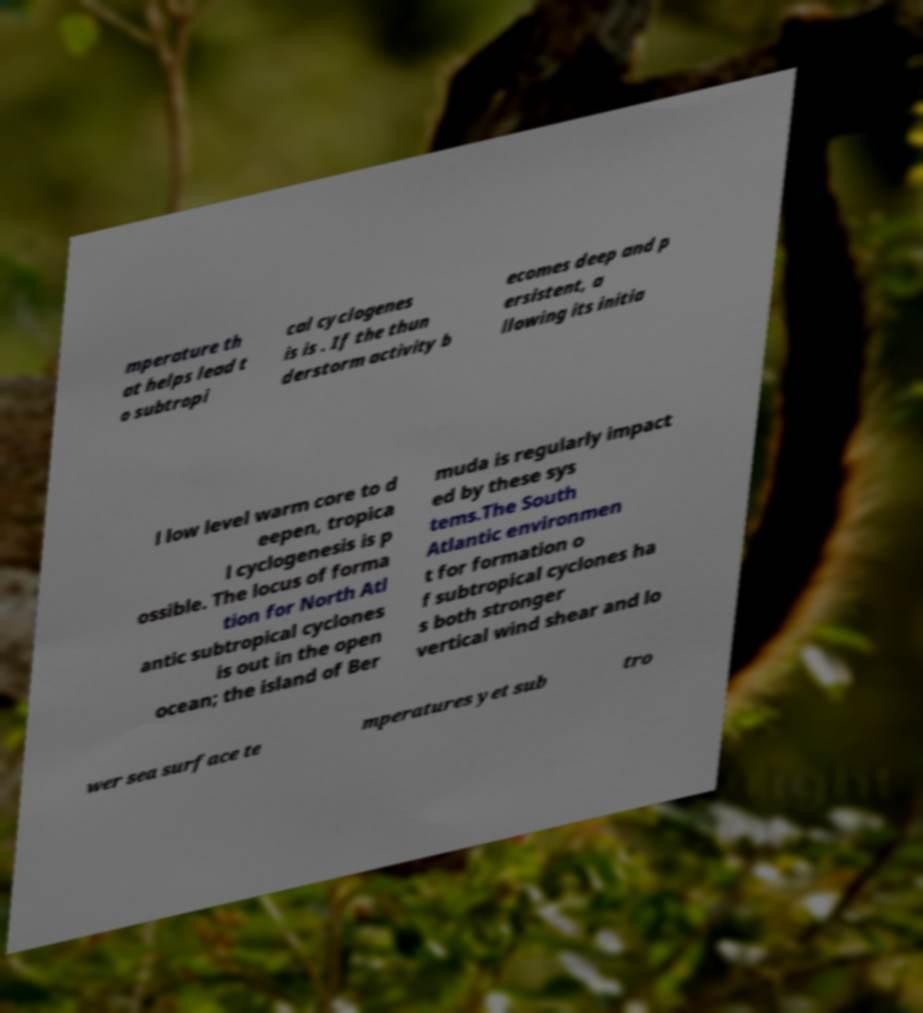I need the written content from this picture converted into text. Can you do that? mperature th at helps lead t o subtropi cal cyclogenes is is . If the thun derstorm activity b ecomes deep and p ersistent, a llowing its initia l low level warm core to d eepen, tropica l cyclogenesis is p ossible. The locus of forma tion for North Atl antic subtropical cyclones is out in the open ocean; the island of Ber muda is regularly impact ed by these sys tems.The South Atlantic environmen t for formation o f subtropical cyclones ha s both stronger vertical wind shear and lo wer sea surface te mperatures yet sub tro 